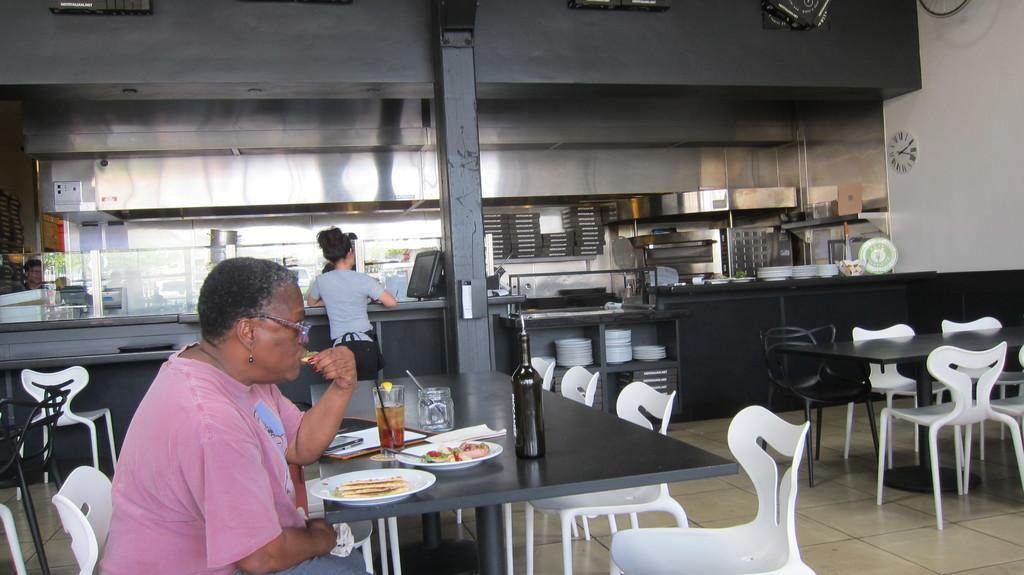Describe this image in one or two sentences. I think this picture is taken in a restaurant. The restaurant is filled with chairs and tables. There is one woman sitting besides a table and having food, on the table there are plates, glass, jar and a bottle. Towards the right there is a table and chairs around it, which is unoccupied. In the background there is a large table and a woman is standing near by it and staring at a computer. There is a pillar in the center. 